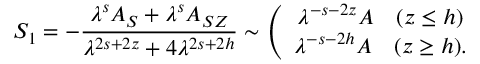<formula> <loc_0><loc_0><loc_500><loc_500>S _ { 1 } = - \frac { \lambda ^ { s } A _ { S } + \lambda ^ { s } A _ { S Z } } { \lambda ^ { 2 s + 2 z } + 4 \lambda ^ { 2 s + 2 h } } \sim \left ( \begin{array} { c } { { \lambda ^ { - s - 2 z } A \quad ( z \leq h ) } } \\ { { \lambda ^ { - s - 2 h } A \quad ( z \geq h ) . } } \end{array}</formula> 